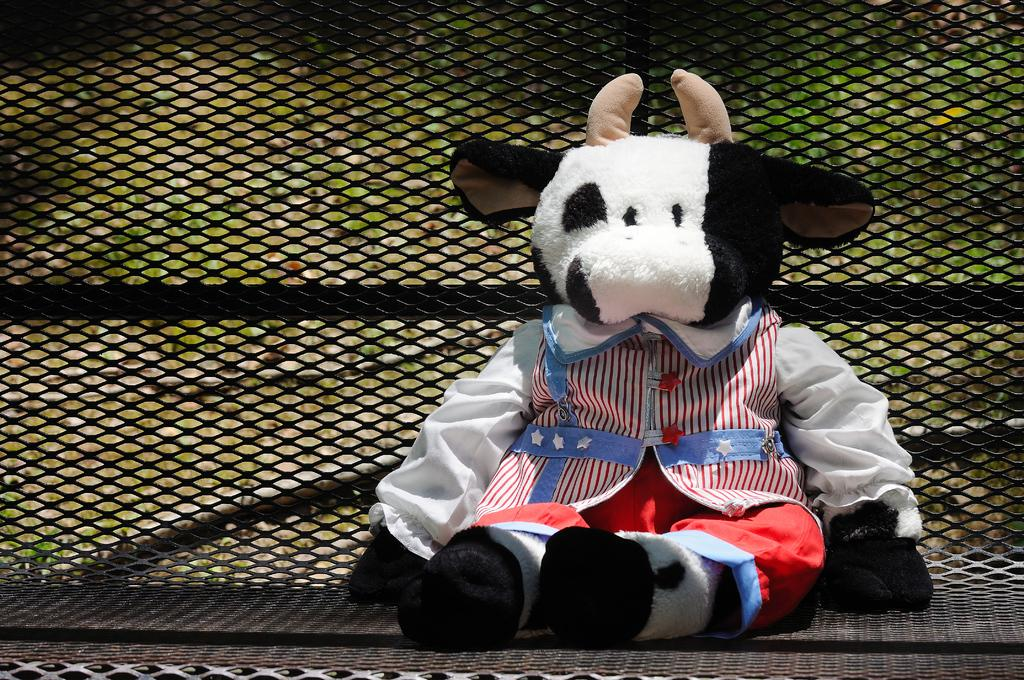What is the main subject in the center of the image? There is a toy in the center of the image. What can be seen in the background of the image? There is a grill in the background of the image. How many people are in the crowd surrounding the toy in the image? There is no crowd present in the image; it only features a toy and a grill in the background. 